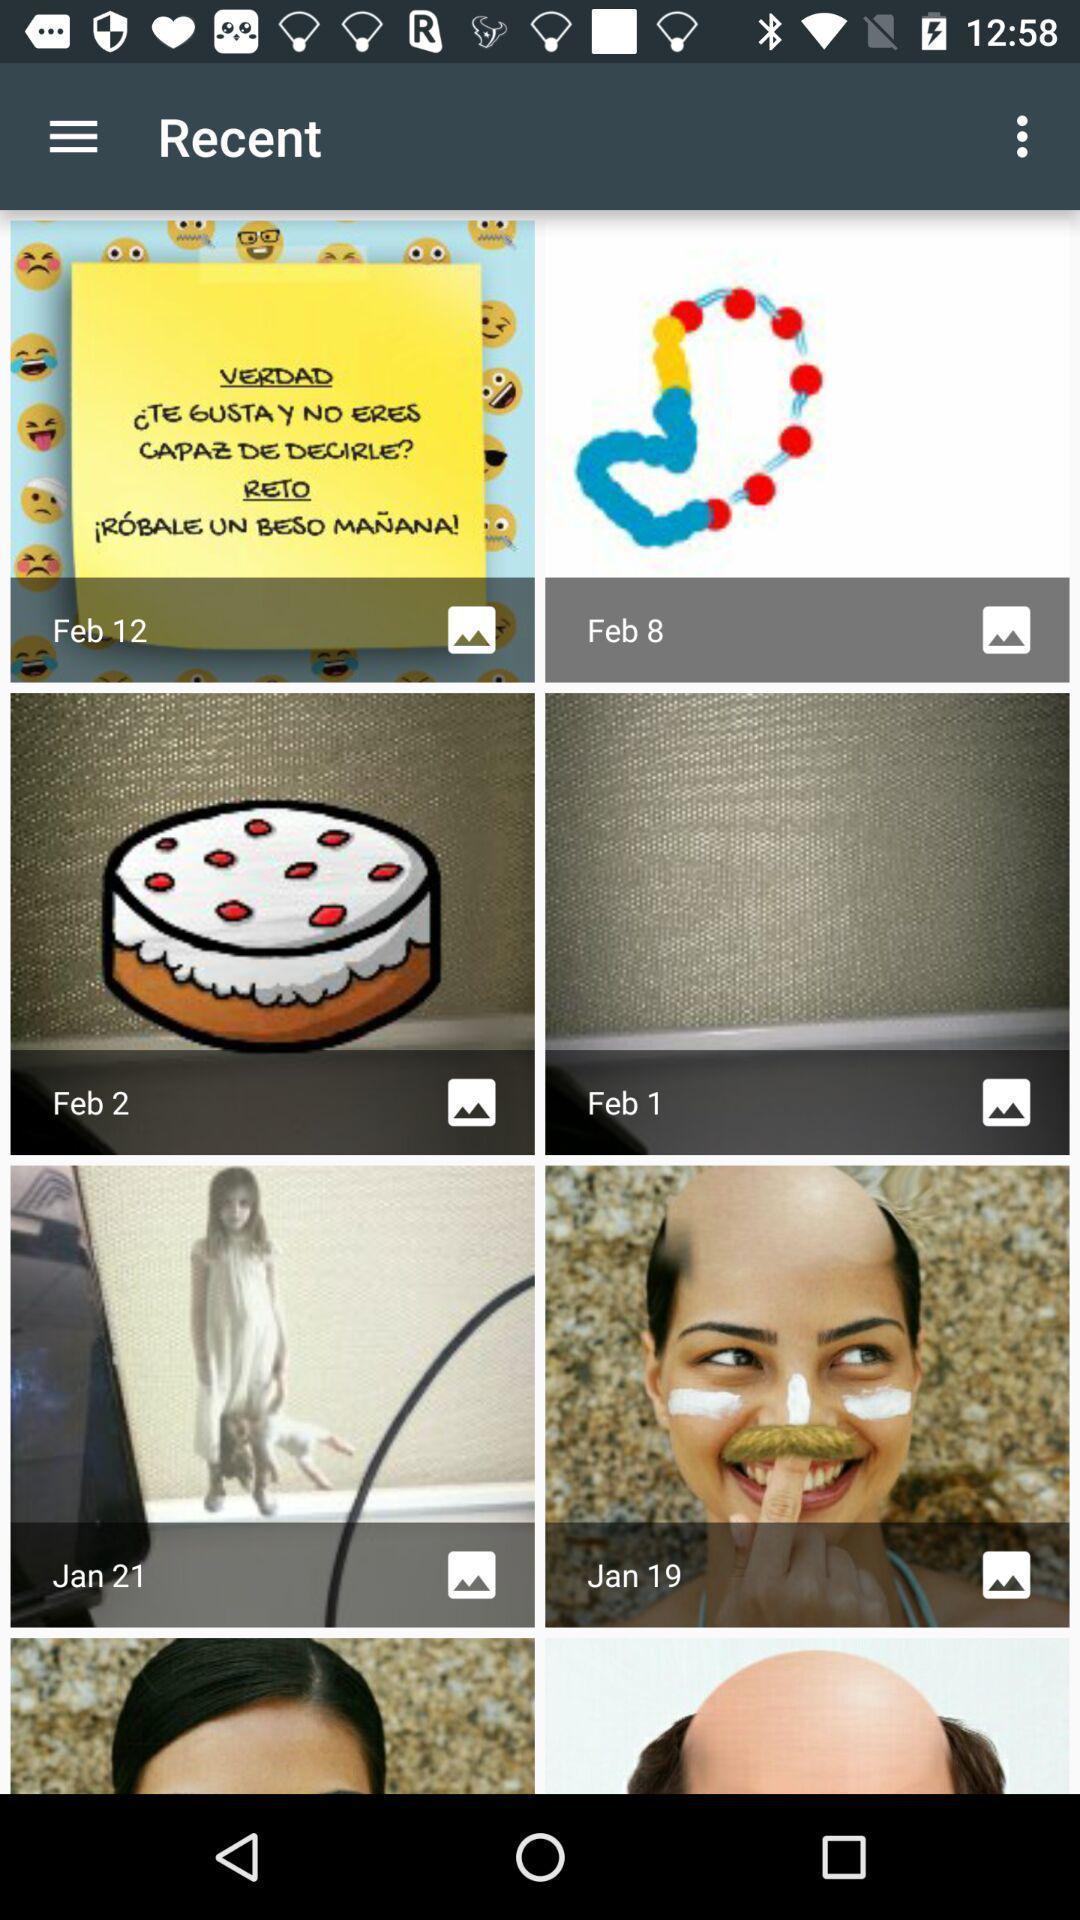Please provide a description for this image. Screen showing images. 